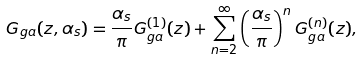Convert formula to latex. <formula><loc_0><loc_0><loc_500><loc_500>G _ { g a } ( z , \alpha _ { s } ) = \frac { \alpha _ { s } } { \pi } G _ { g a } ^ { ( 1 ) } ( z ) + \sum _ { n = 2 } ^ { \infty } \left ( \frac { \alpha _ { s } } { \pi } \right ) ^ { n } G _ { g a } ^ { ( n ) } ( z ) ,</formula> 